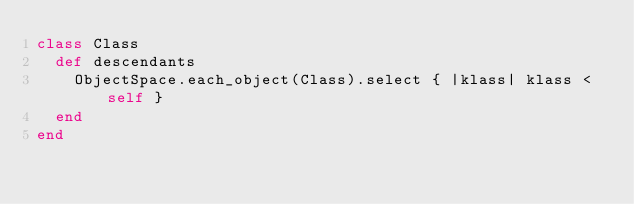Convert code to text. <code><loc_0><loc_0><loc_500><loc_500><_Ruby_>class Class
  def descendants
    ObjectSpace.each_object(Class).select { |klass| klass < self }
  end
end
</code> 